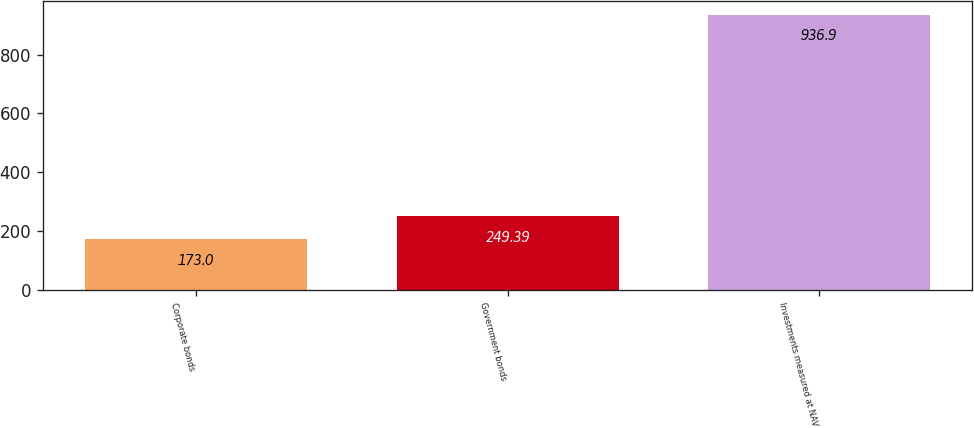Convert chart to OTSL. <chart><loc_0><loc_0><loc_500><loc_500><bar_chart><fcel>Corporate bonds<fcel>Government bonds<fcel>Investments measured at NAV<nl><fcel>173<fcel>249.39<fcel>936.9<nl></chart> 